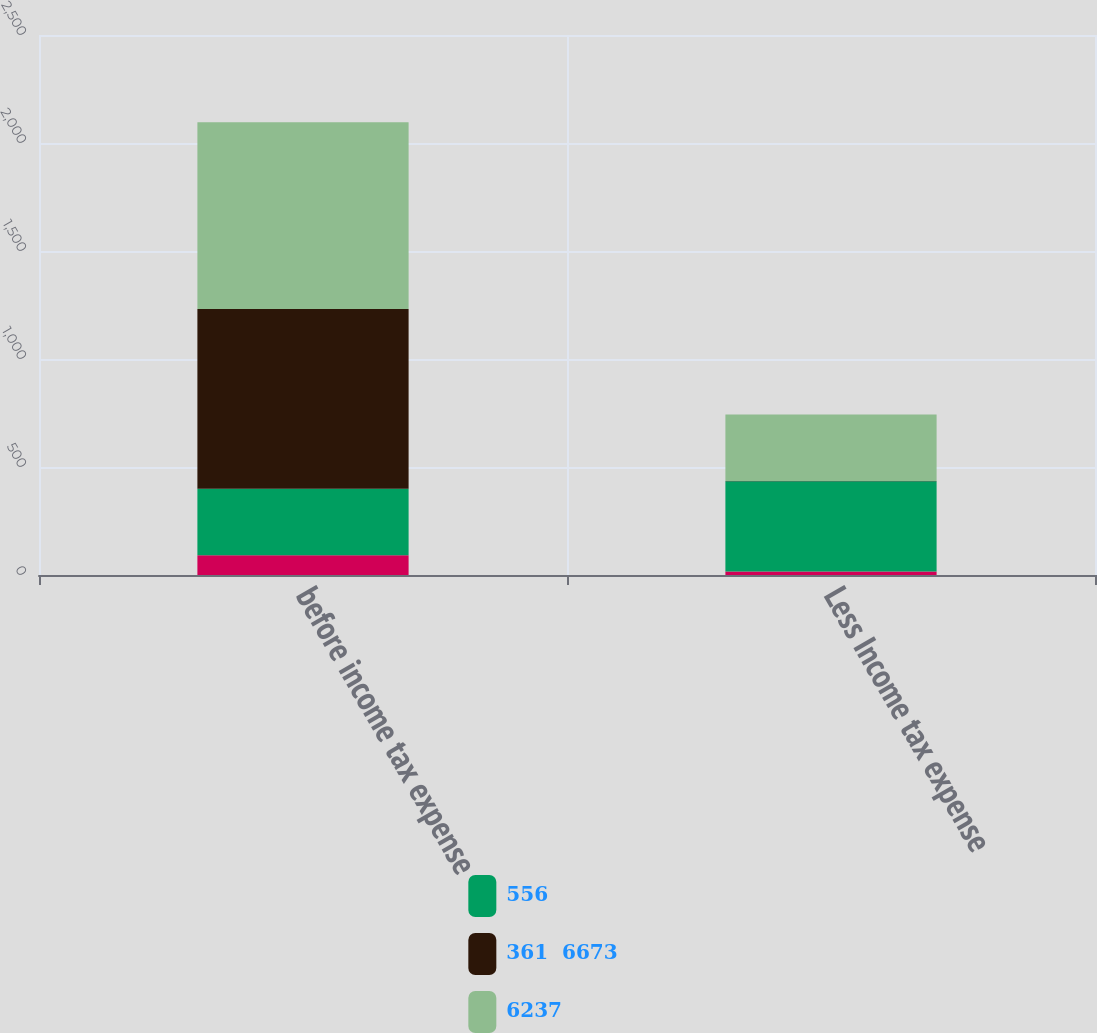Convert chart. <chart><loc_0><loc_0><loc_500><loc_500><stacked_bar_chart><ecel><fcel>before income tax expense<fcel>Less Income tax expense<nl><fcel>nan<fcel>91<fcel>16<nl><fcel>556<fcel>308<fcel>418<nl><fcel>361  6673<fcel>833<fcel>1<nl><fcel>6237<fcel>864<fcel>308<nl></chart> 